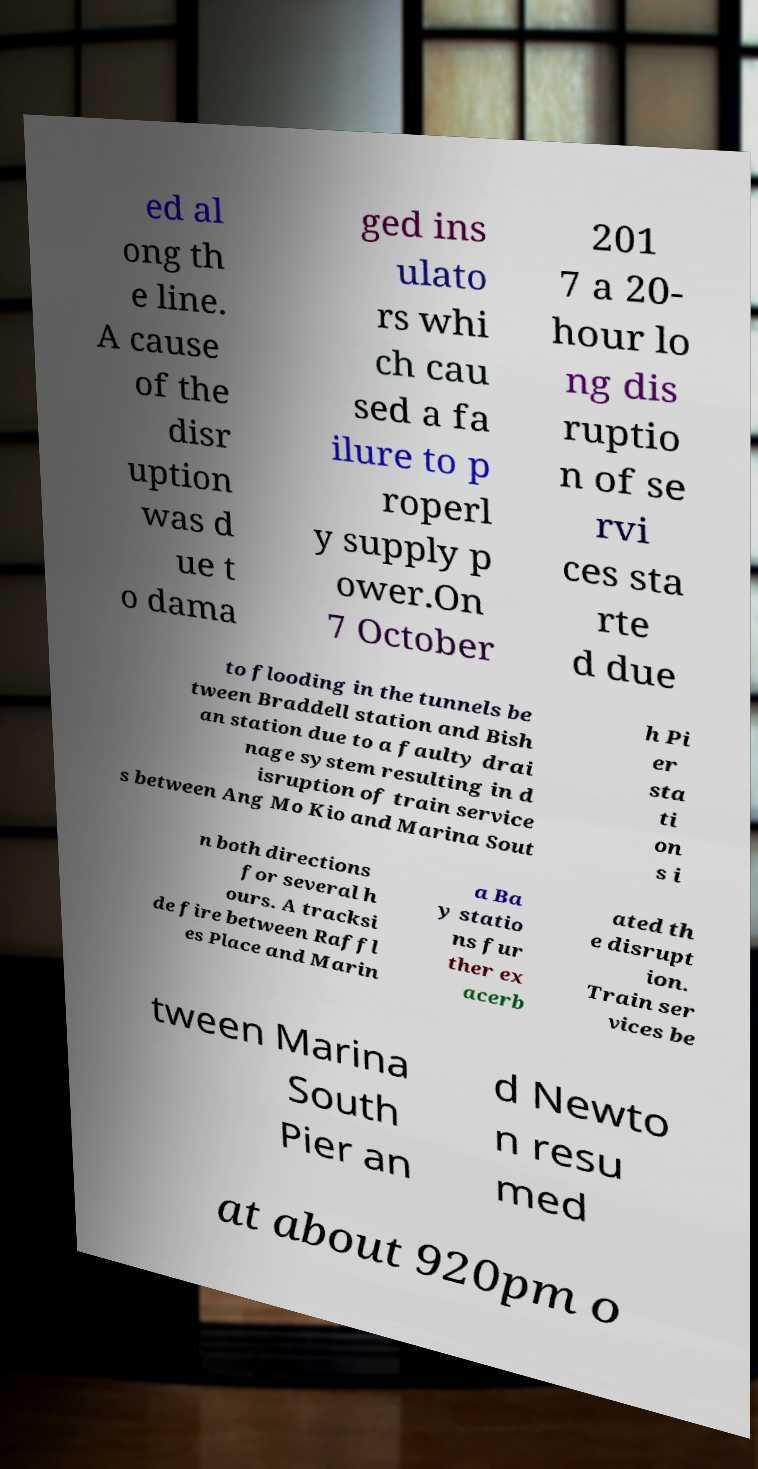For documentation purposes, I need the text within this image transcribed. Could you provide that? ed al ong th e line. A cause of the disr uption was d ue t o dama ged ins ulato rs whi ch cau sed a fa ilure to p roperl y supply p ower.On 7 October 201 7 a 20- hour lo ng dis ruptio n of se rvi ces sta rte d due to flooding in the tunnels be tween Braddell station and Bish an station due to a faulty drai nage system resulting in d isruption of train service s between Ang Mo Kio and Marina Sout h Pi er sta ti on s i n both directions for several h ours. A tracksi de fire between Raffl es Place and Marin a Ba y statio ns fur ther ex acerb ated th e disrupt ion. Train ser vices be tween Marina South Pier an d Newto n resu med at about 920pm o 